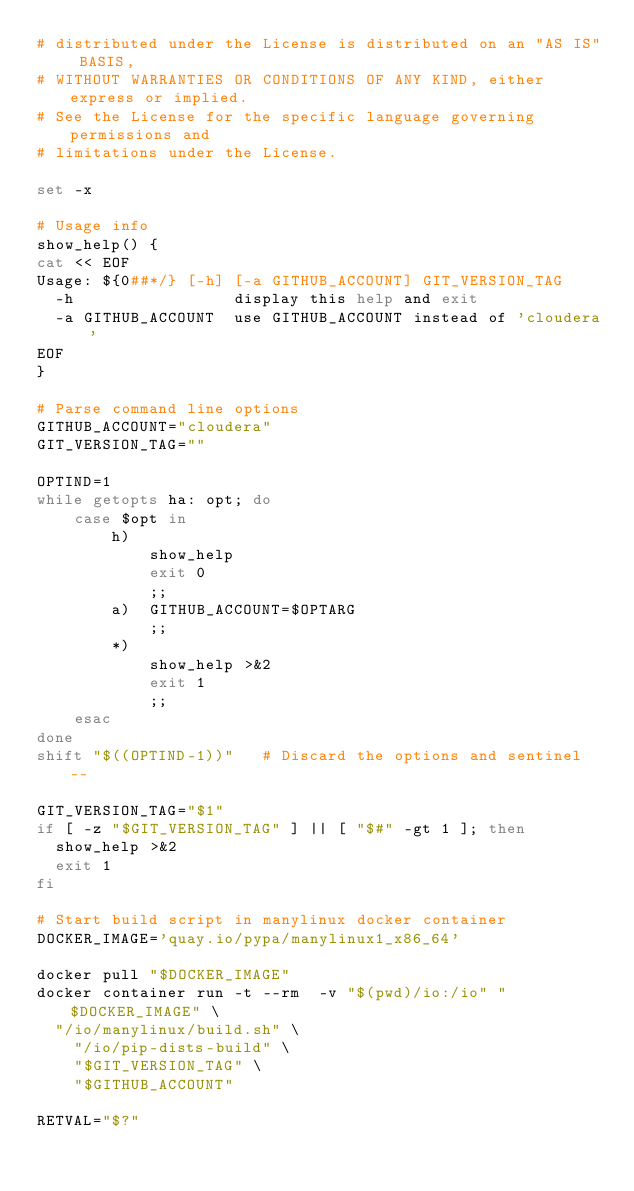Convert code to text. <code><loc_0><loc_0><loc_500><loc_500><_Bash_># distributed under the License is distributed on an "AS IS" BASIS,
# WITHOUT WARRANTIES OR CONDITIONS OF ANY KIND, either express or implied.
# See the License for the specific language governing permissions and
# limitations under the License.

set -x

# Usage info
show_help() {
cat << EOF
Usage: ${0##*/} [-h] [-a GITHUB_ACCOUNT] GIT_VERSION_TAG
  -h                 display this help and exit
  -a GITHUB_ACCOUNT  use GITHUB_ACCOUNT instead of 'cloudera'
EOF
}

# Parse command line options
GITHUB_ACCOUNT="cloudera"
GIT_VERSION_TAG=""

OPTIND=1
while getopts ha: opt; do
    case $opt in
        h)
            show_help
            exit 0
            ;;
        a)  GITHUB_ACCOUNT=$OPTARG
            ;;
        *)
            show_help >&2
            exit 1
            ;;
    esac
done
shift "$((OPTIND-1))"   # Discard the options and sentinel --

GIT_VERSION_TAG="$1"
if [ -z "$GIT_VERSION_TAG" ] || [ "$#" -gt 1 ]; then
  show_help >&2
  exit 1
fi

# Start build script in manylinux docker container
DOCKER_IMAGE='quay.io/pypa/manylinux1_x86_64'

docker pull "$DOCKER_IMAGE"
docker container run -t --rm  -v "$(pwd)/io:/io" "$DOCKER_IMAGE" \
  "/io/manylinux/build.sh" \
    "/io/pip-dists-build" \
    "$GIT_VERSION_TAG" \
    "$GITHUB_ACCOUNT"

RETVAL="$?"</code> 